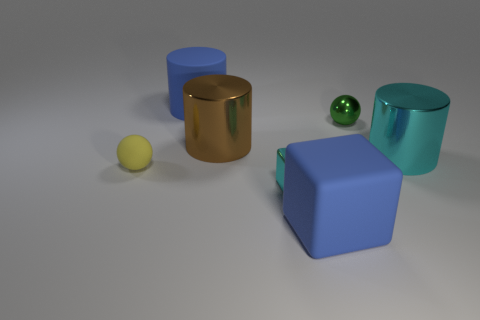How many green metallic objects have the same size as the blue matte cylinder?
Offer a very short reply. 0. Is the material of the large blue thing that is in front of the blue matte cylinder the same as the ball on the left side of the blue matte block?
Provide a succinct answer. Yes. There is a sphere in front of the brown metal cylinder that is right of the yellow matte object; what is it made of?
Offer a terse response. Rubber. What is the material of the blue object behind the metallic ball?
Keep it short and to the point. Rubber. How many small green objects have the same shape as the brown shiny object?
Ensure brevity in your answer.  0. Is the color of the large matte cube the same as the rubber cylinder?
Offer a very short reply. Yes. What material is the tiny sphere that is right of the blue object that is left of the big rubber thing that is in front of the large rubber cylinder?
Offer a terse response. Metal. There is a tiny green metallic object; are there any metal objects on the left side of it?
Make the answer very short. Yes. There is a green metal thing that is the same size as the yellow thing; what shape is it?
Ensure brevity in your answer.  Sphere. Does the large cyan cylinder have the same material as the small cube?
Offer a very short reply. Yes. 